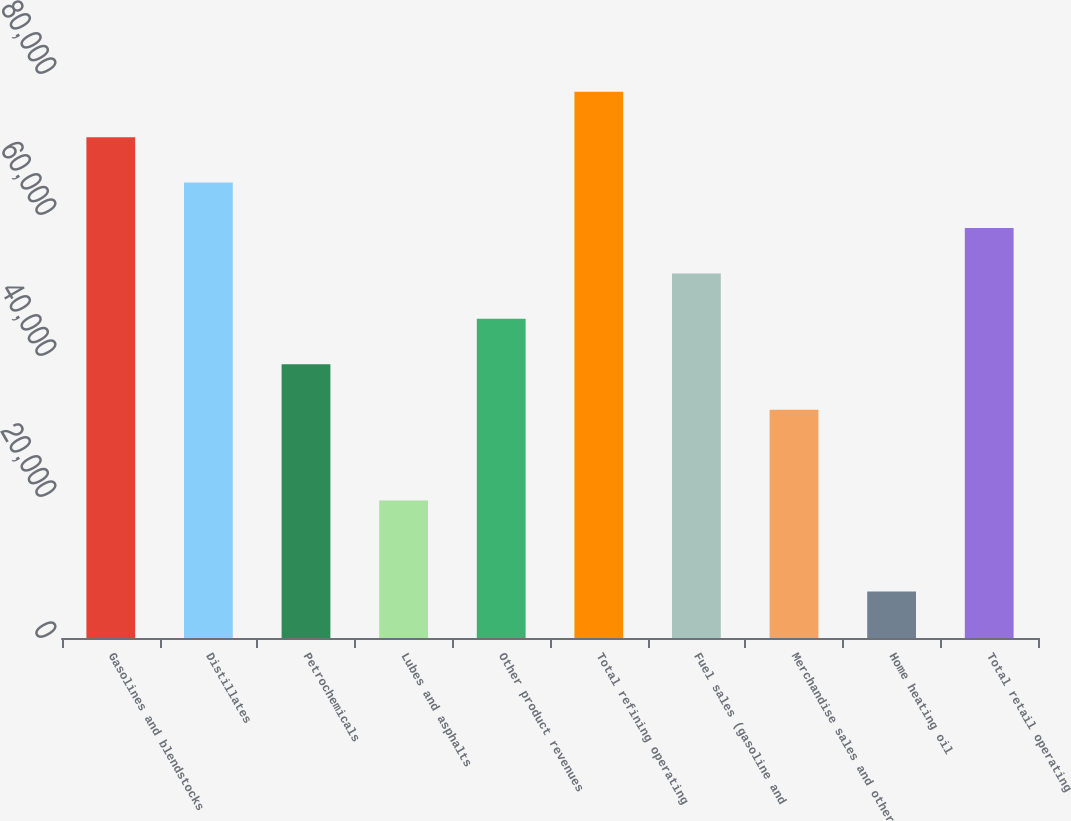Convert chart to OTSL. <chart><loc_0><loc_0><loc_500><loc_500><bar_chart><fcel>Gasolines and blendstocks<fcel>Distillates<fcel>Petrochemicals<fcel>Lubes and asphalts<fcel>Other product revenues<fcel>Total refining operating<fcel>Fuel sales (gasoline and<fcel>Merchandise sales and other<fcel>Home heating oil<fcel>Total retail operating<nl><fcel>71042.3<fcel>64599<fcel>38825.8<fcel>19495.9<fcel>45269.1<fcel>77485.6<fcel>51712.4<fcel>32382.5<fcel>6609.3<fcel>58155.7<nl></chart> 